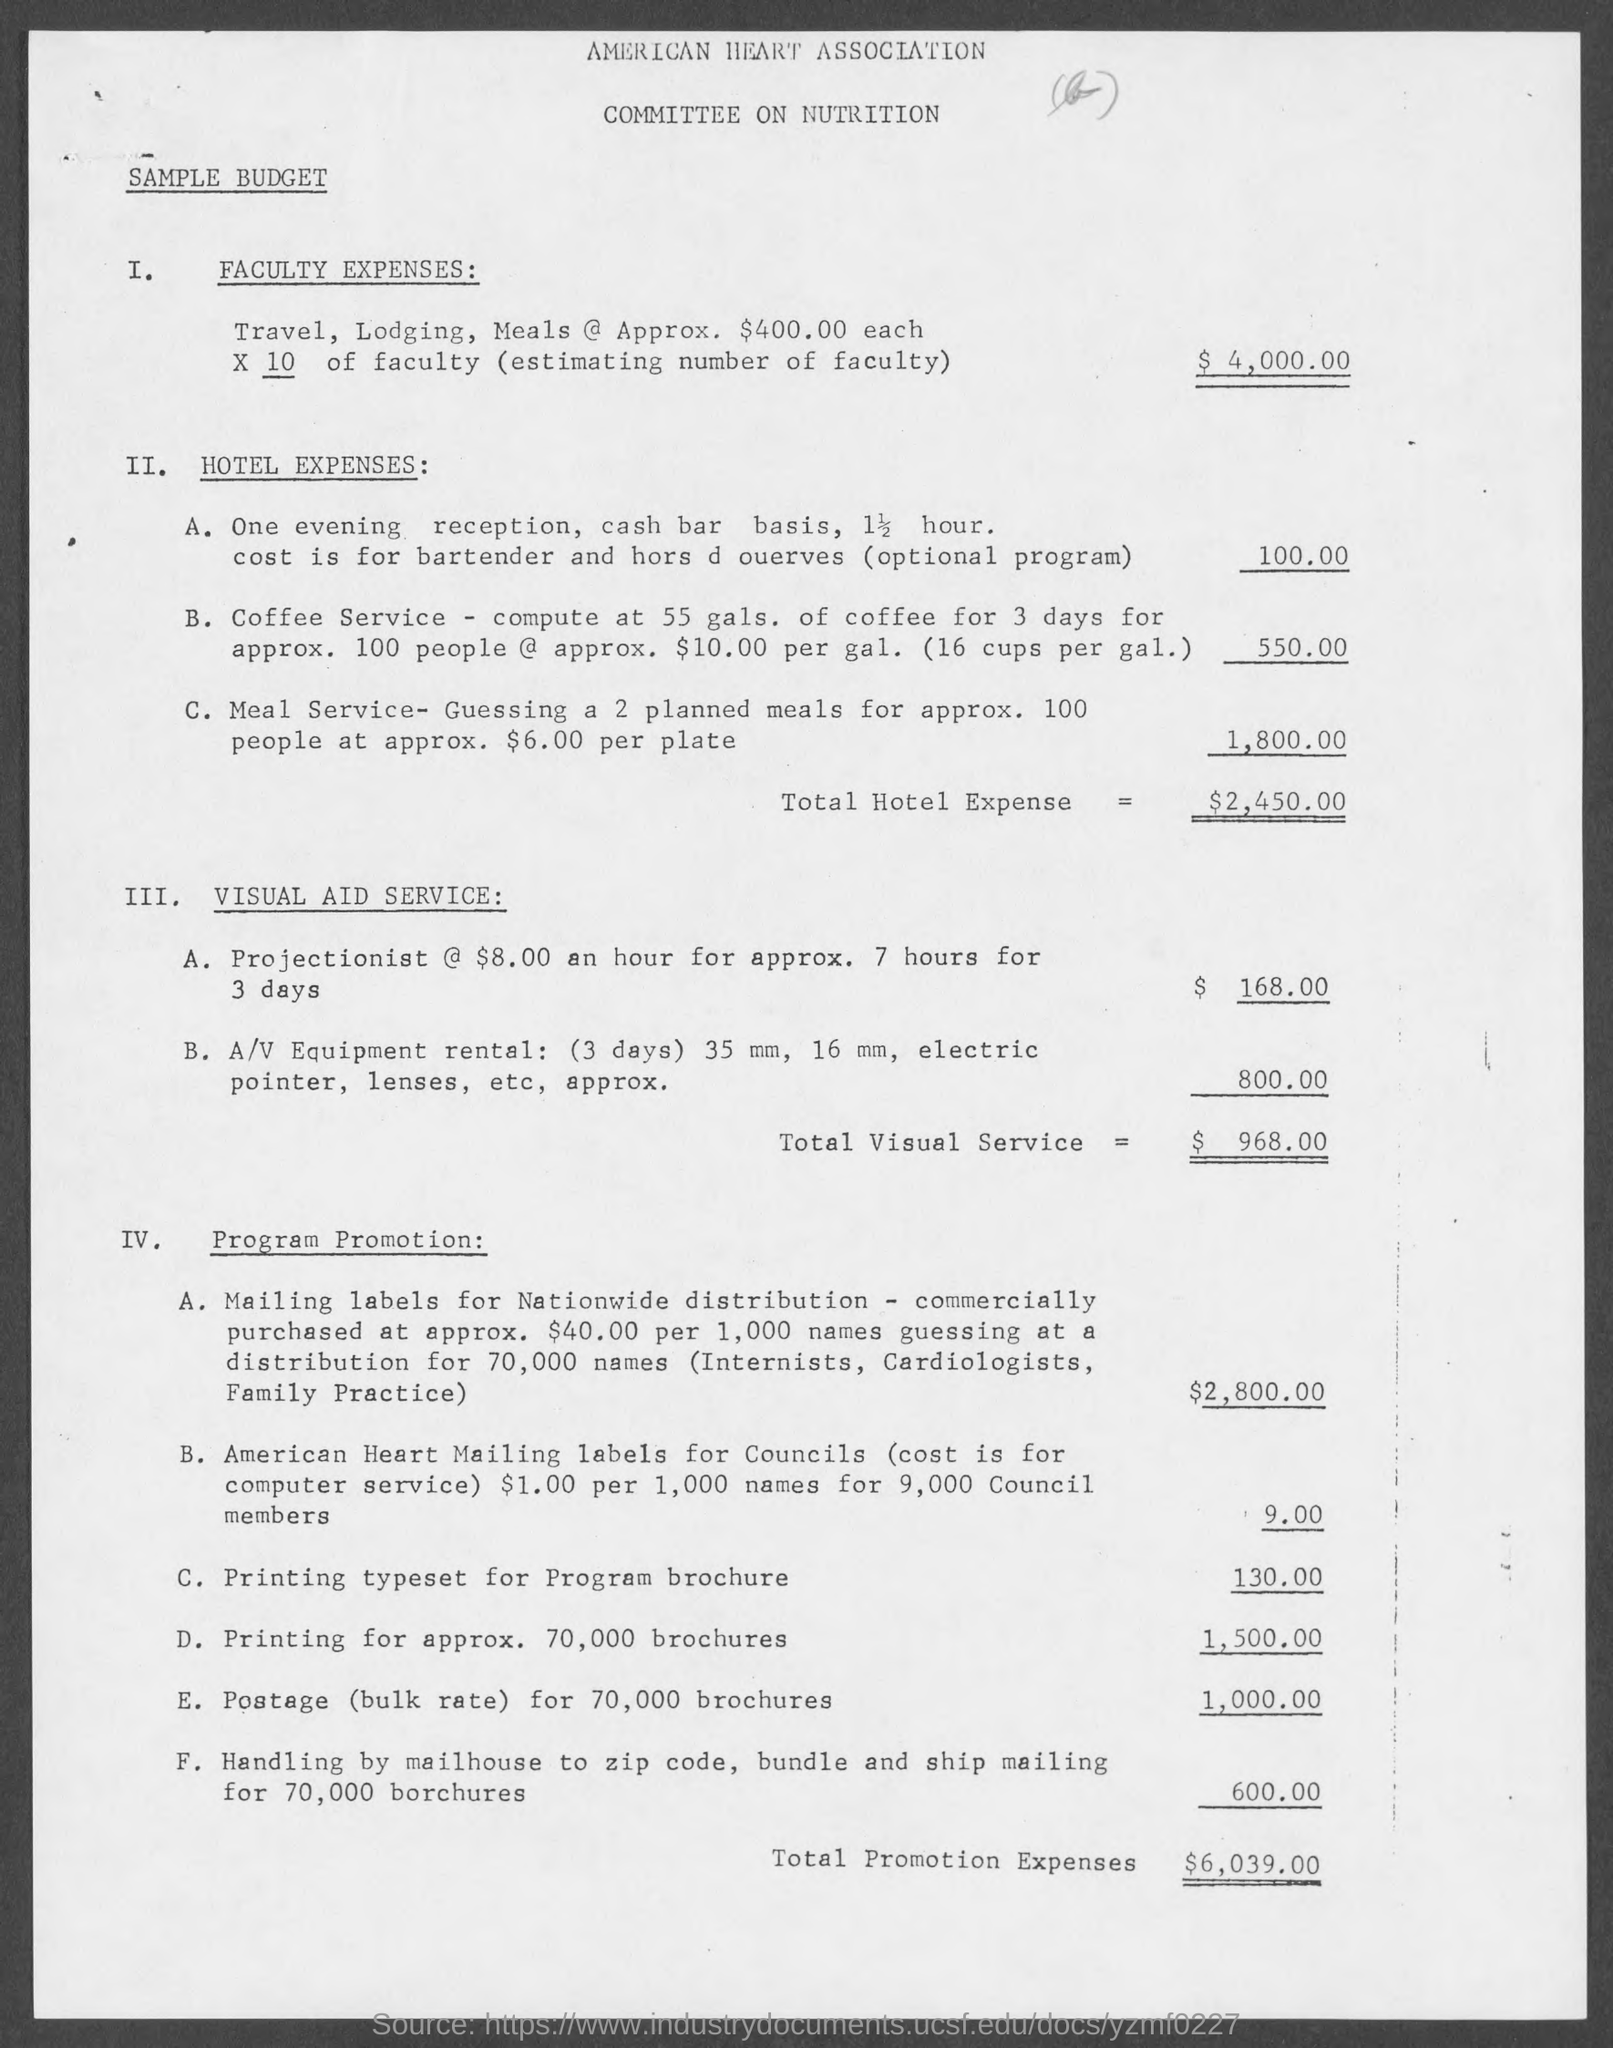Give some essential details in this illustration. The total amount of promotion expenses was $6,039.00. 